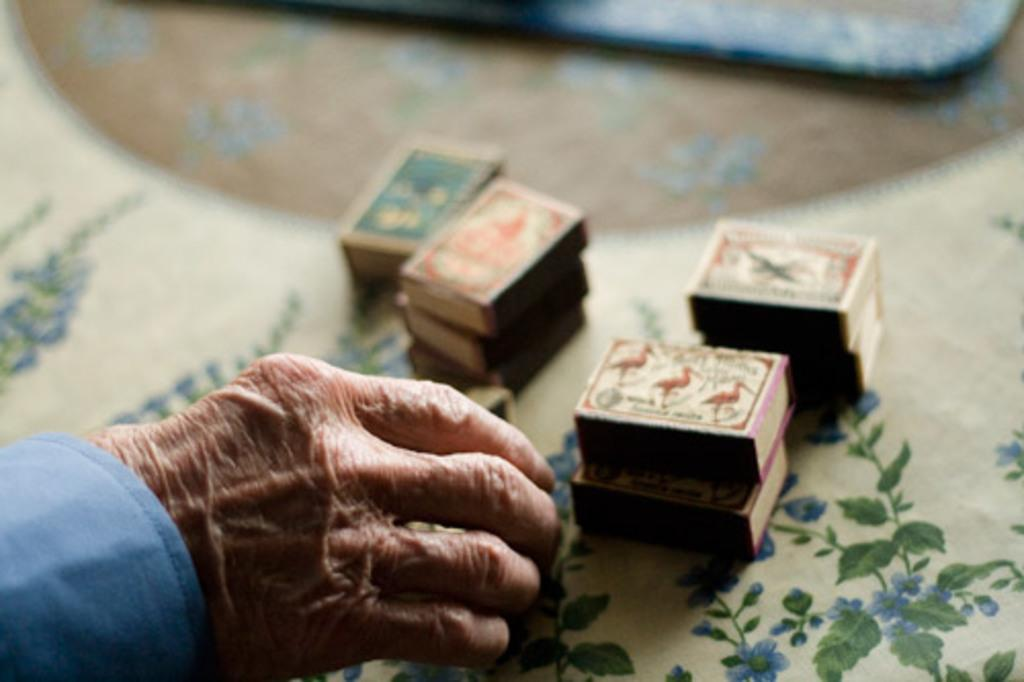What objects are on the cloth in the image? There are matchboxes on the cloth in the image. Can you describe any other elements in the image? The hand of a person is visible in the image. What type of plantation can be seen in the background of the image? There is no plantation visible in the image; it only shows matchboxes on a cloth and a hand. What kind of brush is being used by the person in the image? There is no brush present in the image; only matchboxes and a hand are visible. 